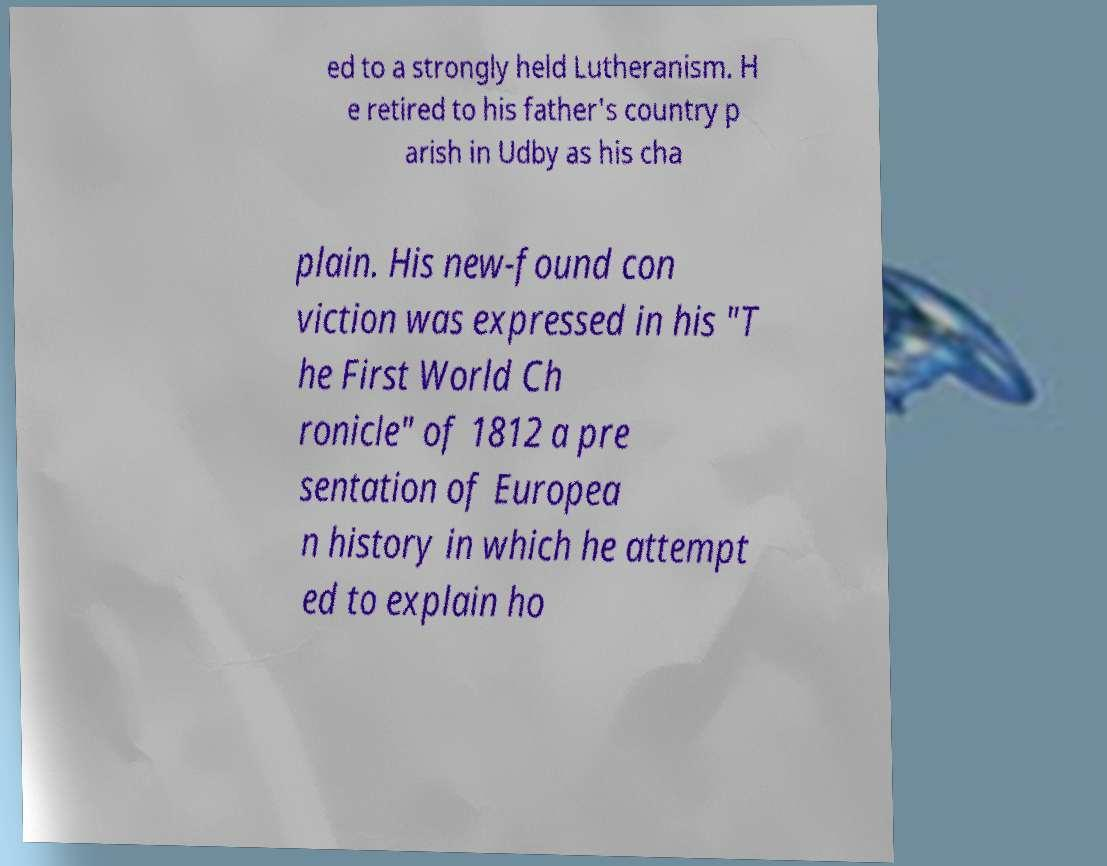What messages or text are displayed in this image? I need them in a readable, typed format. ed to a strongly held Lutheranism. H e retired to his father's country p arish in Udby as his cha plain. His new-found con viction was expressed in his "T he First World Ch ronicle" of 1812 a pre sentation of Europea n history in which he attempt ed to explain ho 